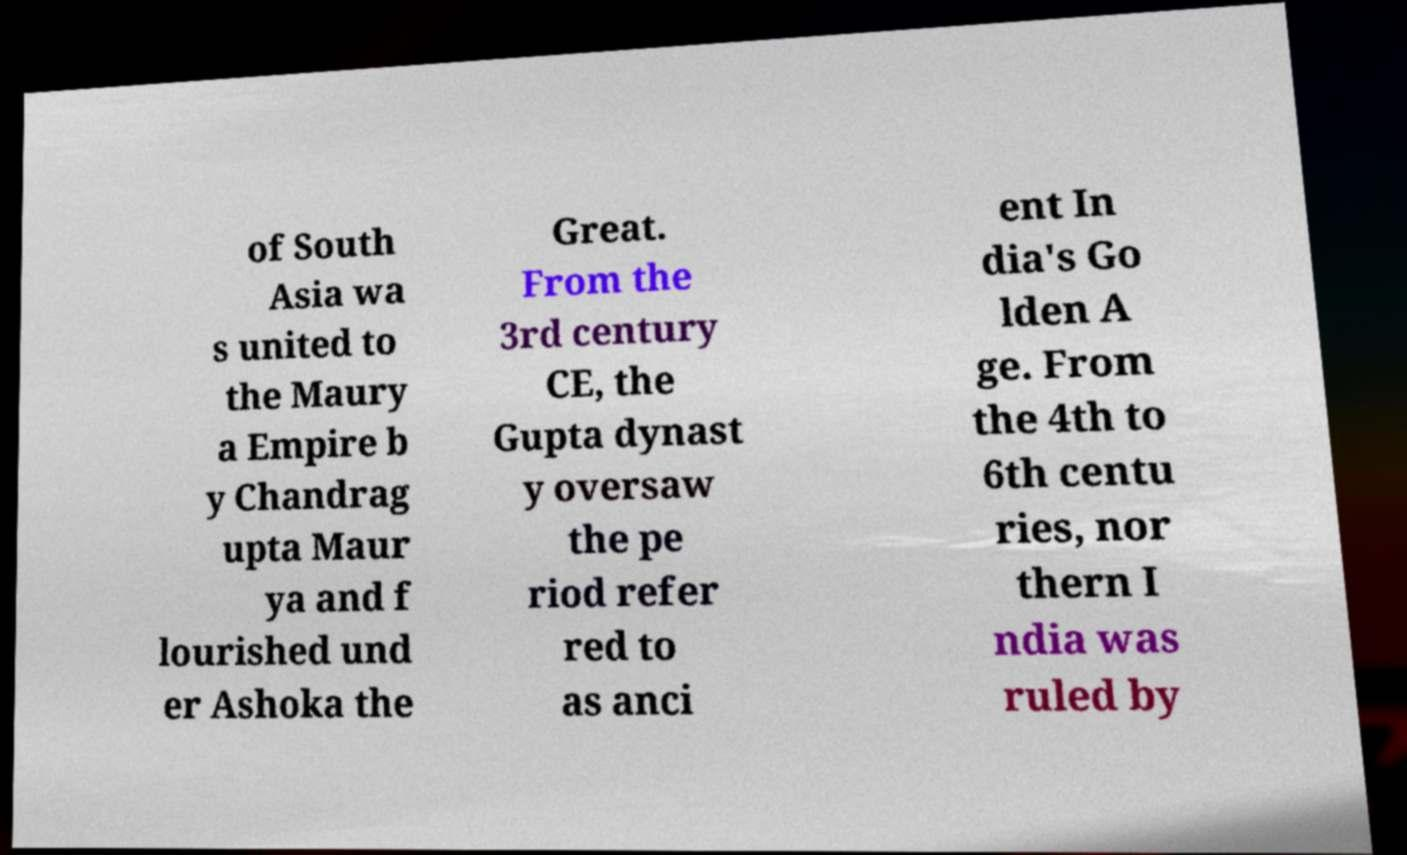What messages or text are displayed in this image? I need them in a readable, typed format. of South Asia wa s united to the Maury a Empire b y Chandrag upta Maur ya and f lourished und er Ashoka the Great. From the 3rd century CE, the Gupta dynast y oversaw the pe riod refer red to as anci ent In dia's Go lden A ge. From the 4th to 6th centu ries, nor thern I ndia was ruled by 